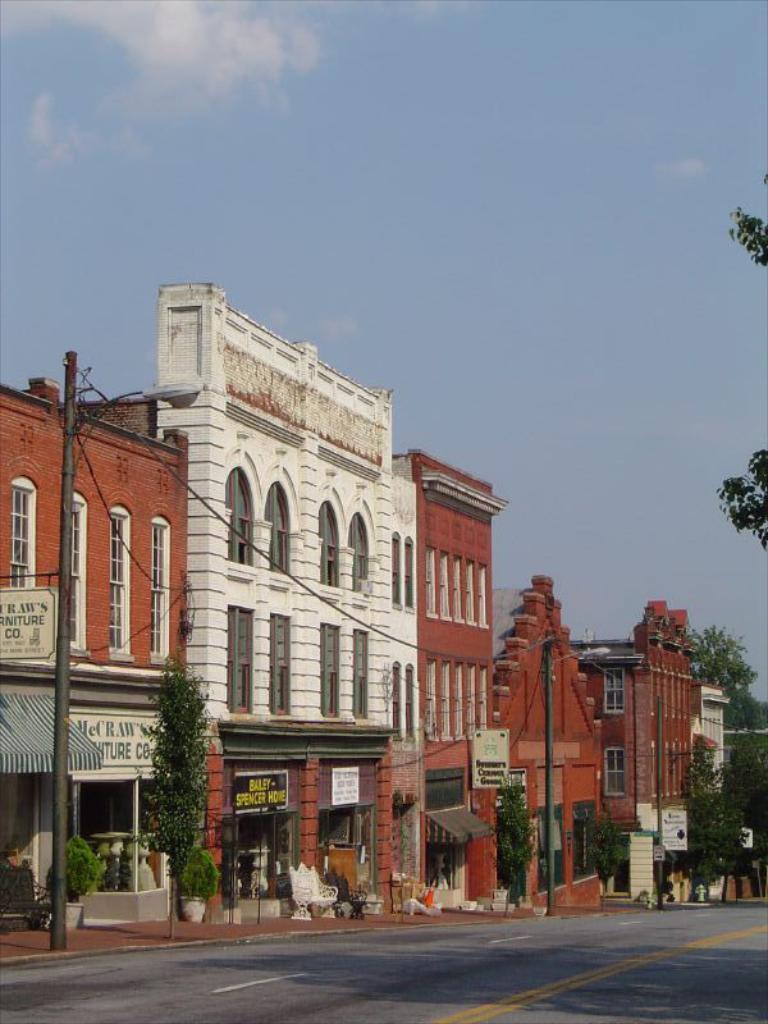Could you give a brief overview of what you see in this image? At the bottom of this image I can see the road. In the background there are some buildings, poles and trees. On the right side I can see the leaves of a tree. On the top of the image I can see the sky. 